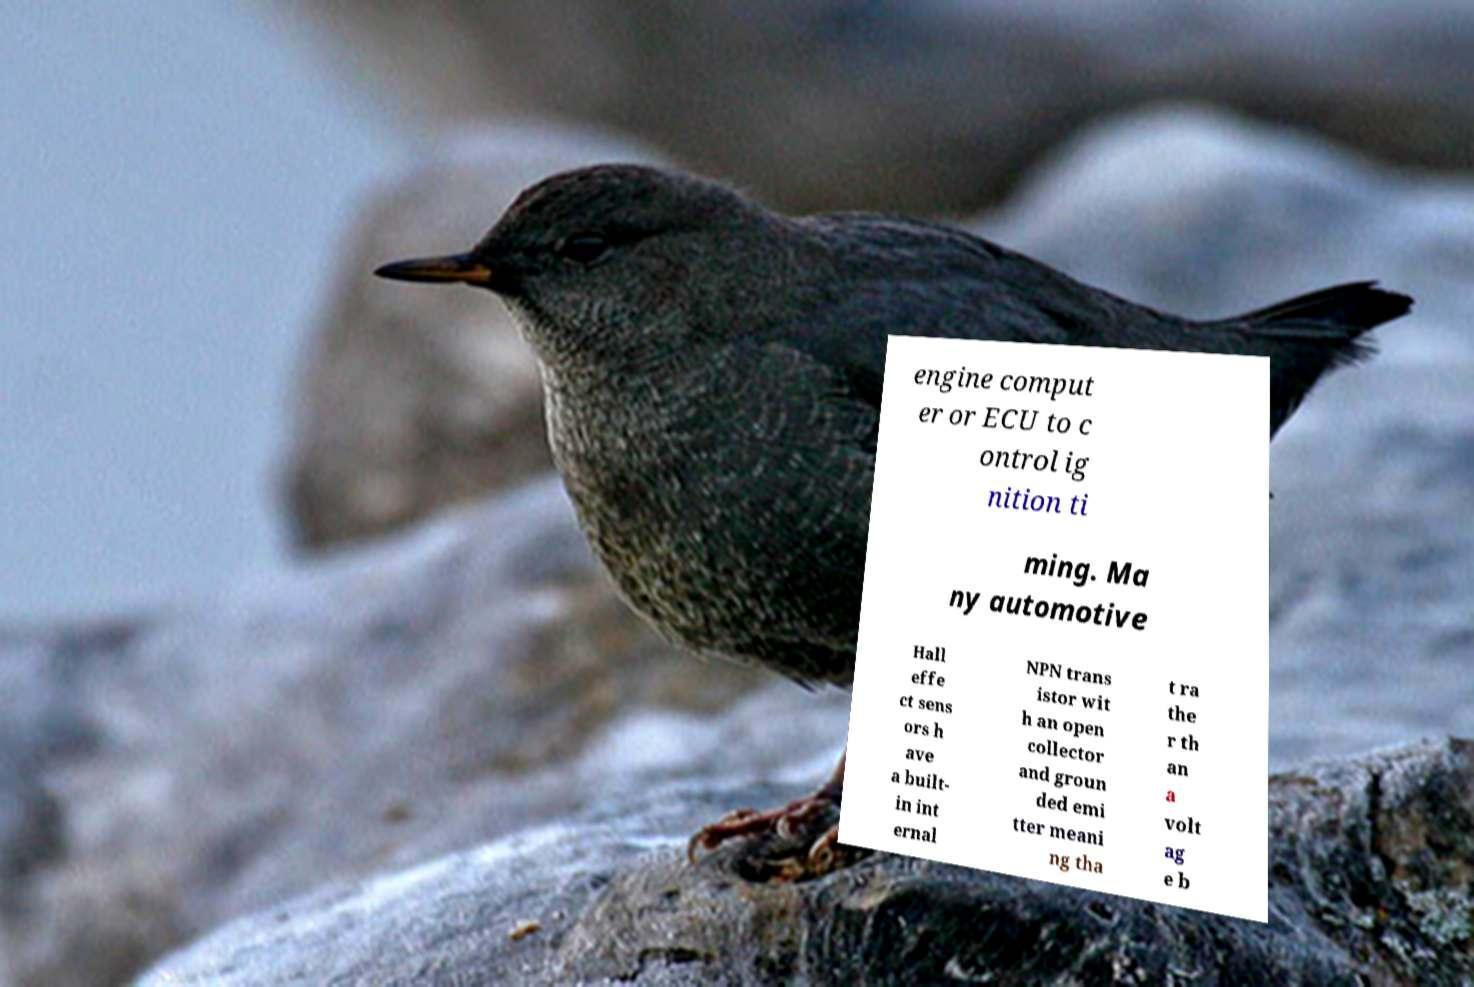Can you accurately transcribe the text from the provided image for me? engine comput er or ECU to c ontrol ig nition ti ming. Ma ny automotive Hall effe ct sens ors h ave a built- in int ernal NPN trans istor wit h an open collector and groun ded emi tter meani ng tha t ra the r th an a volt ag e b 